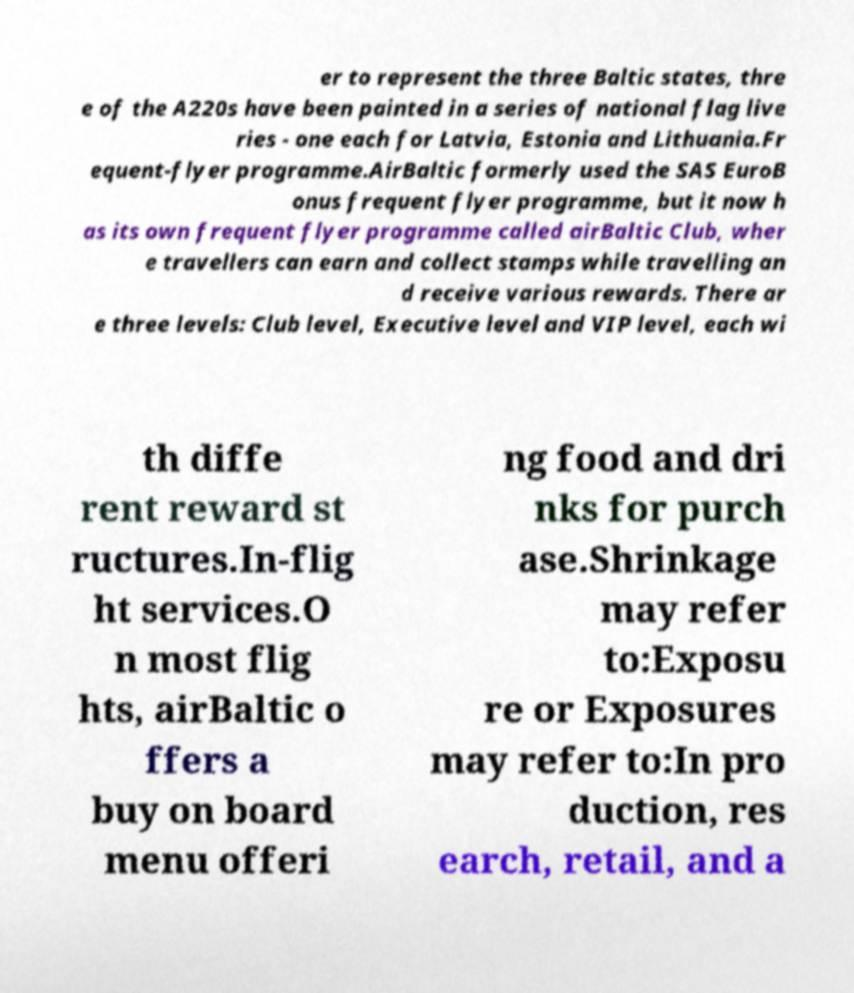Please read and relay the text visible in this image. What does it say? er to represent the three Baltic states, thre e of the A220s have been painted in a series of national flag live ries - one each for Latvia, Estonia and Lithuania.Fr equent-flyer programme.AirBaltic formerly used the SAS EuroB onus frequent flyer programme, but it now h as its own frequent flyer programme called airBaltic Club, wher e travellers can earn and collect stamps while travelling an d receive various rewards. There ar e three levels: Club level, Executive level and VIP level, each wi th diffe rent reward st ructures.In-flig ht services.O n most flig hts, airBaltic o ffers a buy on board menu offeri ng food and dri nks for purch ase.Shrinkage may refer to:Exposu re or Exposures may refer to:In pro duction, res earch, retail, and a 